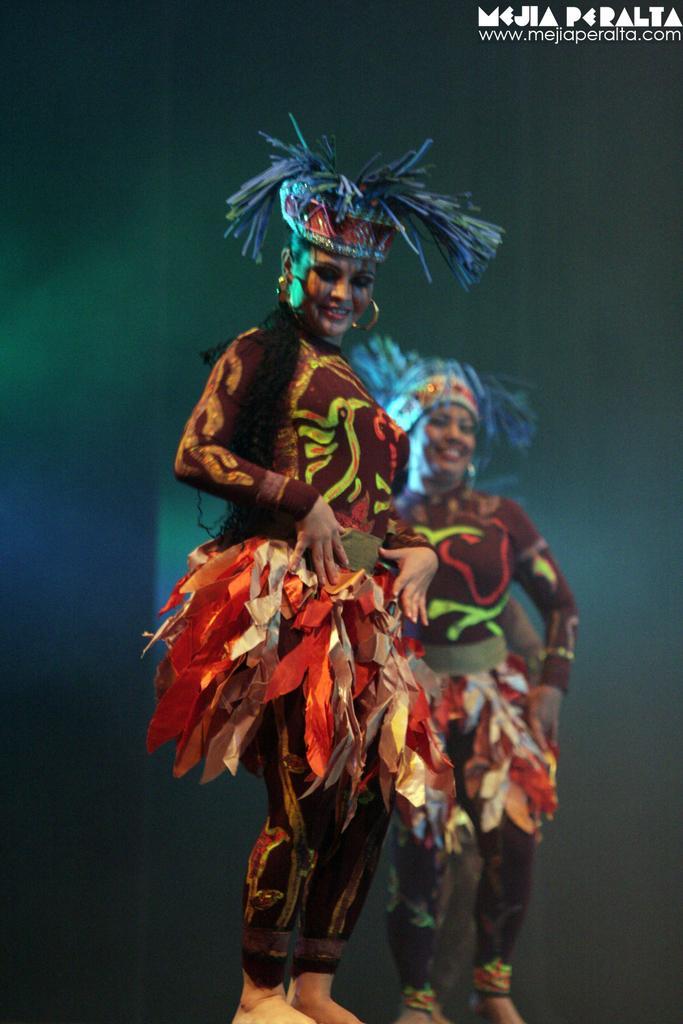Could you give a brief overview of what you see in this image? This image consists of two women wearing costumes and dancing. The hair color is blue. The dress is in brown and red color. 